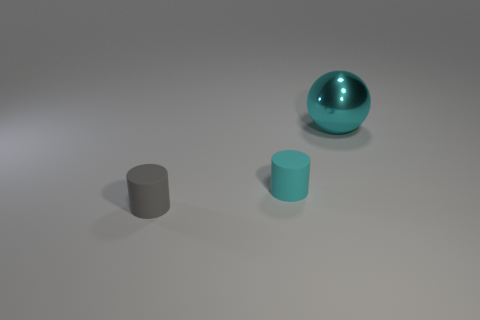Are there any other things that have the same material as the cyan ball?
Offer a terse response. No. What is the shape of the small gray object?
Offer a very short reply. Cylinder. The cylinder that is the same material as the tiny gray object is what color?
Provide a short and direct response. Cyan. Are there more large metallic spheres than yellow metallic blocks?
Keep it short and to the point. Yes. Are there any tiny brown rubber cylinders?
Give a very brief answer. No. There is a gray matte object that is in front of the cyan object in front of the shiny object; what shape is it?
Your answer should be very brief. Cylinder. What number of objects are tiny cyan cylinders or cyan things on the left side of the shiny sphere?
Your answer should be very brief. 1. There is a tiny thing that is behind the matte thing on the left side of the cyan thing that is left of the cyan metal ball; what is its color?
Ensure brevity in your answer.  Cyan. There is a tiny gray thing that is the same shape as the tiny cyan matte object; what is it made of?
Offer a very short reply. Rubber. What is the color of the big object?
Ensure brevity in your answer.  Cyan. 